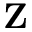<formula> <loc_0><loc_0><loc_500><loc_500>{ Z }</formula> 